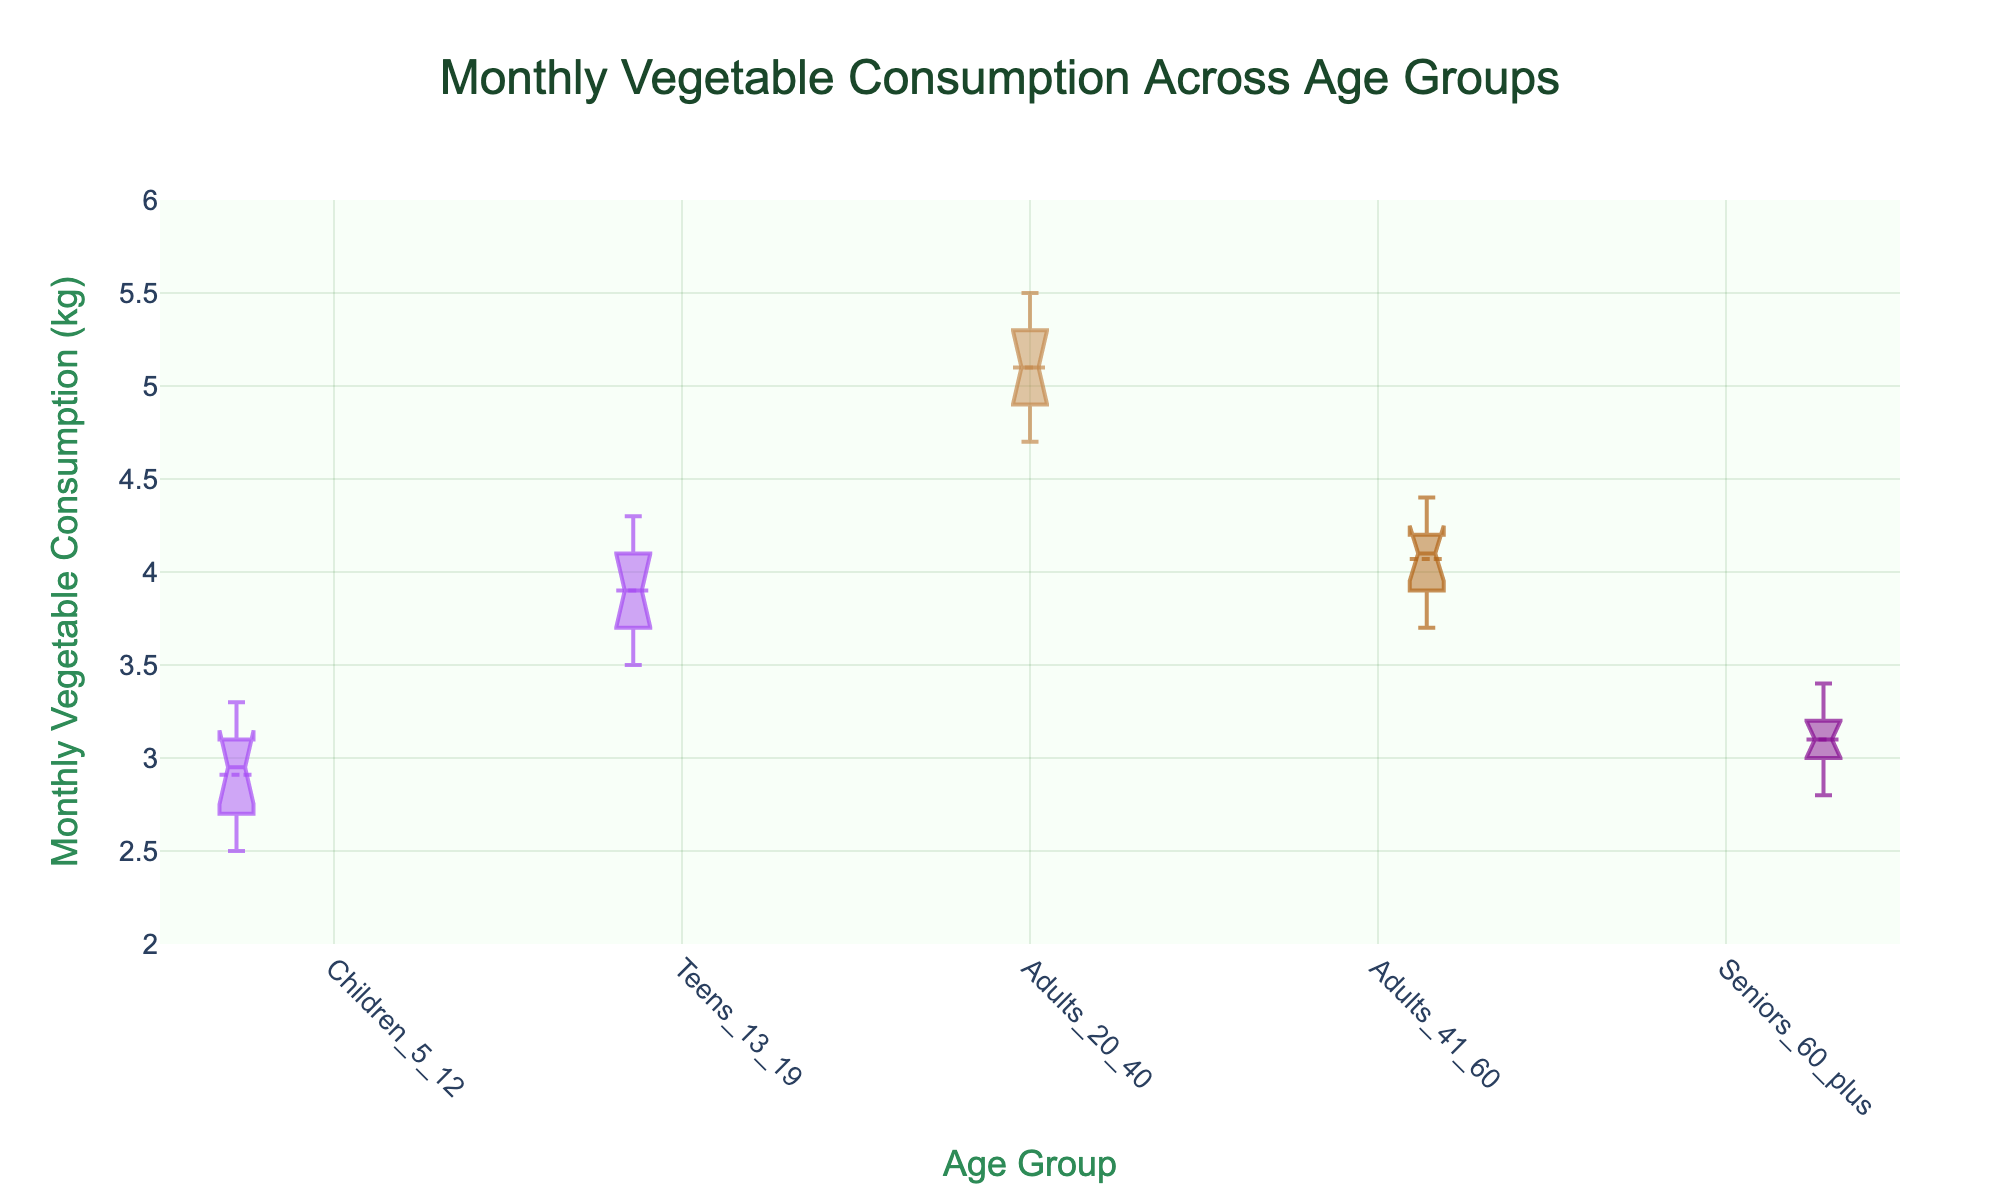What is the title of the figure? The title is located at the top of the figure and is usually a summary of the content presented. In this case, it describes what the whole figure is about.
Answer: Monthly Vegetable Consumption Across Age Groups Which age group has the widest notches? By looking at the figure, the notches for each group can be compared visually. The wider the notch, the less precise the median estimation.
Answer: Teens 13-19 In which age group is the median vegetable consumption the highest? Locate the notches in the middle of each box plot, which represent the median, and determine which is the highest on the y-axis.
Answer: Adults 20-40 What is the interquartile range (IQR) of the 'Adults 41-60' age group? The IQR is the difference between the third quartile (top of the box) and the first quartile (bottom of the box). Observe these positions on the y-axis for the 'Adults 41-60' box plot.
Answer: 4.2 - 3.9 = 0.3 kg Which age group has the smallest median monthly vegetable consumption, and what is its approximate value? Examine the notch at the center of each box plot and identify the smallest one on the y-axis.
Answer: Children 5-12; approx. 3 kg What can you infer about the spread (variability) of vegetable consumption in 'Teens 13-19' compared to 'Adults 20-40'? Check the length of the boxes (representing the interquartile range) and the length of the whiskers (showing variability) for both age groups.
Answer: Teens 13-19 have more spread How do the interquartile ranges (IQR) compare between 'Seniors 60+' and 'Children 5-12'? Compare the lengths of the boxes for both age groups. The IQR gives an idea about the middle 50% of the data.
Answer: Seniors 60+ have a smaller IQR Which age group appears to have the highest variability in their vegetable consumption? Assess the total length of the whiskers and box for each group, as well as any outliers, which indicate variability.
Answer: 'Teens 13-19' Are there any outliers in the 'Adults 41-60' age group? Identify any points outside the whiskers for this age group. Outliers are those points that appear distinctly separate from the rest.
Answer: No Based on the notched box plot, which two age groups have overlapping medians? Look at the notches of each box plot and see which pairs overlap with each other, indicating that their medians are not significantly different.
Answer: Children 5-12 and 'Seniors 60+' 